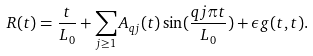<formula> <loc_0><loc_0><loc_500><loc_500>R ( t ) = \frac { t } { L _ { 0 } } + \sum _ { j \geq 1 } A _ { q j } ( t ) \sin ( \frac { q j \pi t } { L _ { 0 } } ) + \epsilon g ( t , t ) .</formula> 